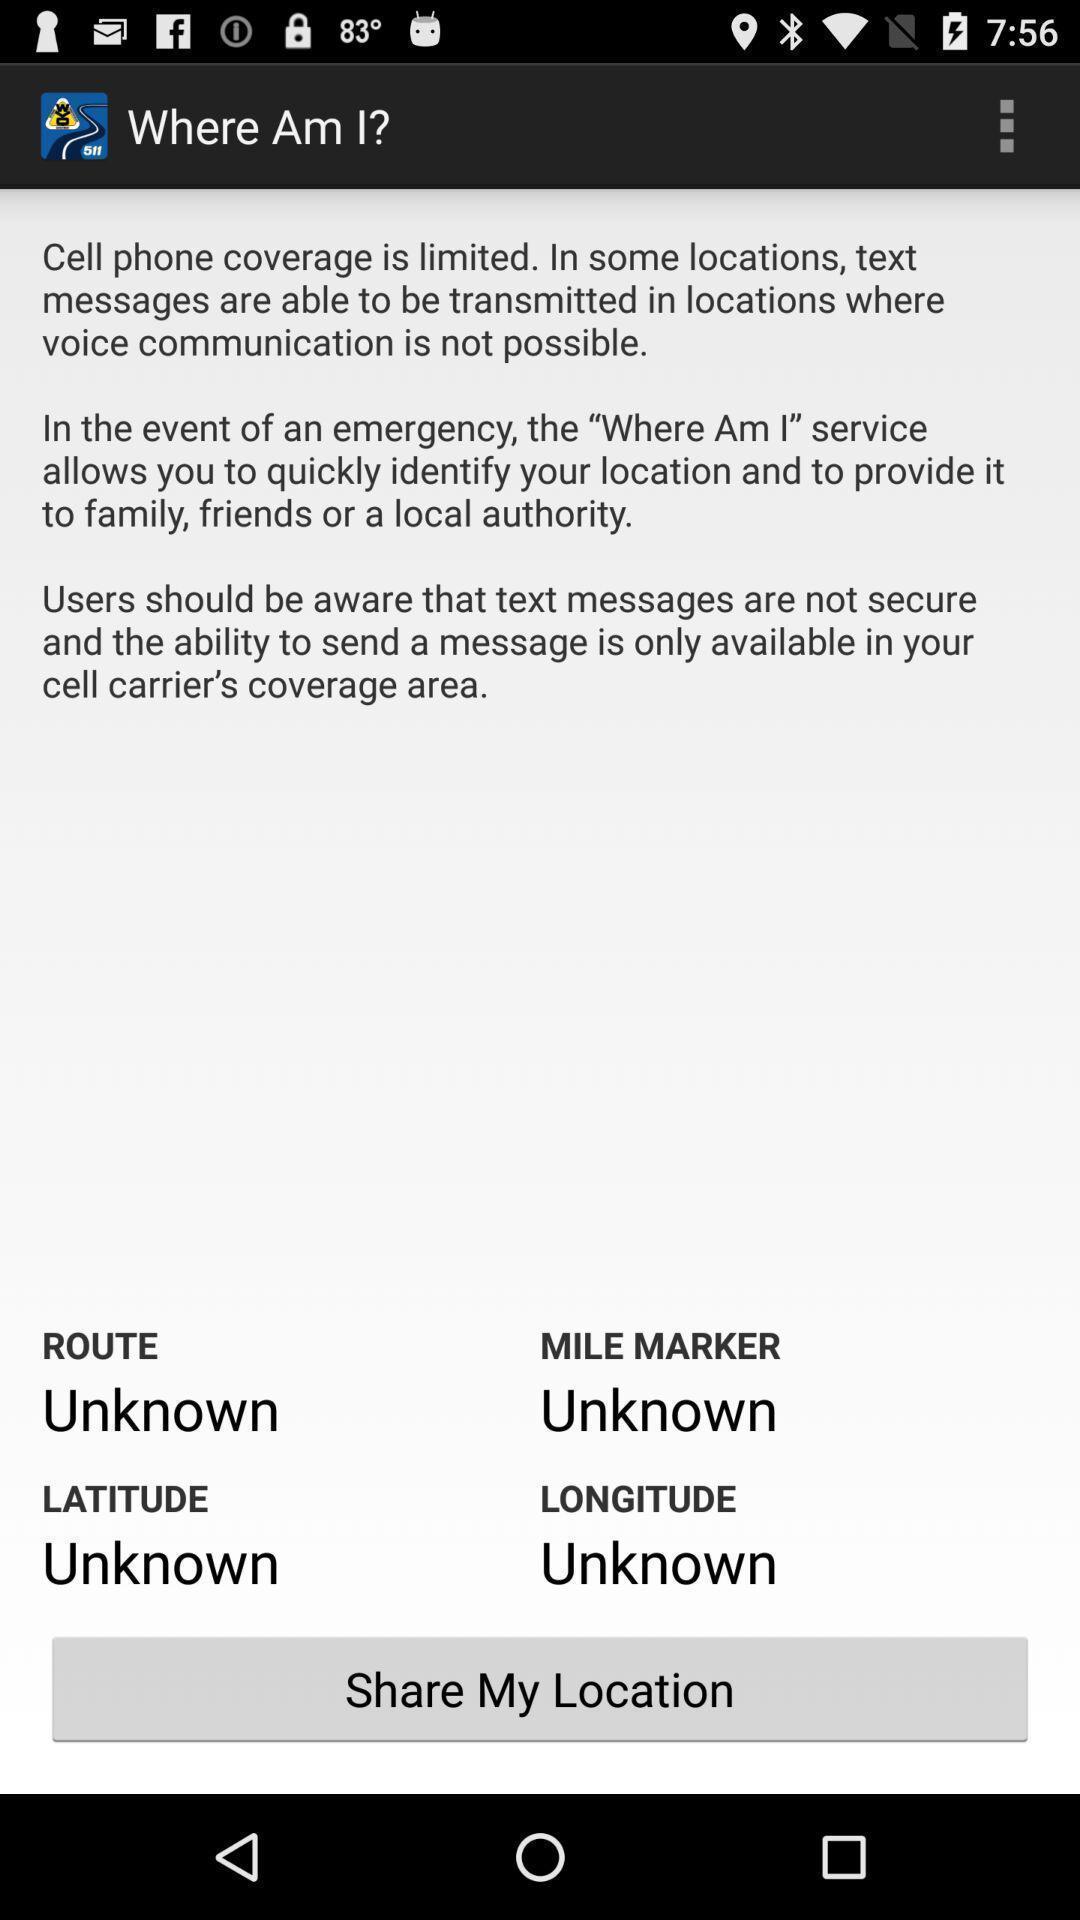Describe the key features of this screenshot. Screen showing some mobile phone coverage app. 